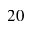Convert formula to latex. <formula><loc_0><loc_0><loc_500><loc_500>2 0</formula> 